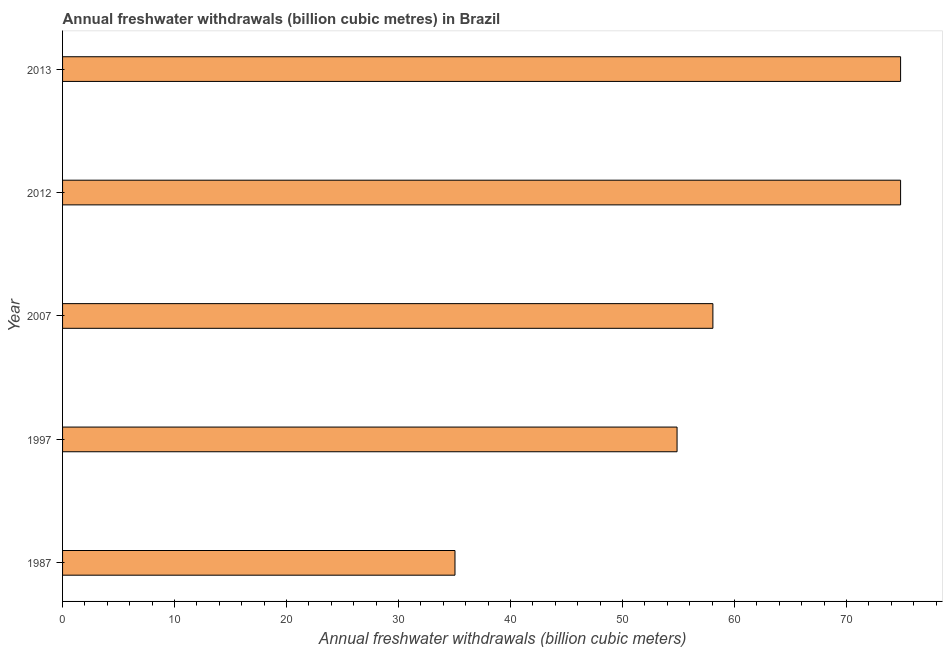What is the title of the graph?
Offer a very short reply. Annual freshwater withdrawals (billion cubic metres) in Brazil. What is the label or title of the X-axis?
Offer a terse response. Annual freshwater withdrawals (billion cubic meters). What is the annual freshwater withdrawals in 2013?
Your response must be concise. 74.83. Across all years, what is the maximum annual freshwater withdrawals?
Provide a succinct answer. 74.83. Across all years, what is the minimum annual freshwater withdrawals?
Your answer should be compact. 35.04. In which year was the annual freshwater withdrawals minimum?
Your answer should be compact. 1987. What is the sum of the annual freshwater withdrawals?
Your response must be concise. 297.64. What is the difference between the annual freshwater withdrawals in 1997 and 2013?
Your response must be concise. -19.96. What is the average annual freshwater withdrawals per year?
Give a very brief answer. 59.53. What is the median annual freshwater withdrawals?
Keep it short and to the point. 58.07. What is the ratio of the annual freshwater withdrawals in 1997 to that in 2013?
Ensure brevity in your answer.  0.73. What is the difference between the highest and the second highest annual freshwater withdrawals?
Offer a very short reply. 0. What is the difference between the highest and the lowest annual freshwater withdrawals?
Offer a terse response. 39.79. In how many years, is the annual freshwater withdrawals greater than the average annual freshwater withdrawals taken over all years?
Give a very brief answer. 2. Are all the bars in the graph horizontal?
Give a very brief answer. Yes. How many years are there in the graph?
Provide a succinct answer. 5. What is the difference between two consecutive major ticks on the X-axis?
Keep it short and to the point. 10. What is the Annual freshwater withdrawals (billion cubic meters) of 1987?
Offer a very short reply. 35.04. What is the Annual freshwater withdrawals (billion cubic meters) in 1997?
Your answer should be compact. 54.87. What is the Annual freshwater withdrawals (billion cubic meters) of 2007?
Your answer should be compact. 58.07. What is the Annual freshwater withdrawals (billion cubic meters) in 2012?
Make the answer very short. 74.83. What is the Annual freshwater withdrawals (billion cubic meters) of 2013?
Your answer should be compact. 74.83. What is the difference between the Annual freshwater withdrawals (billion cubic meters) in 1987 and 1997?
Give a very brief answer. -19.83. What is the difference between the Annual freshwater withdrawals (billion cubic meters) in 1987 and 2007?
Provide a short and direct response. -23.03. What is the difference between the Annual freshwater withdrawals (billion cubic meters) in 1987 and 2012?
Offer a terse response. -39.79. What is the difference between the Annual freshwater withdrawals (billion cubic meters) in 1987 and 2013?
Your answer should be compact. -39.79. What is the difference between the Annual freshwater withdrawals (billion cubic meters) in 1997 and 2007?
Your response must be concise. -3.2. What is the difference between the Annual freshwater withdrawals (billion cubic meters) in 1997 and 2012?
Your answer should be very brief. -19.96. What is the difference between the Annual freshwater withdrawals (billion cubic meters) in 1997 and 2013?
Give a very brief answer. -19.96. What is the difference between the Annual freshwater withdrawals (billion cubic meters) in 2007 and 2012?
Keep it short and to the point. -16.76. What is the difference between the Annual freshwater withdrawals (billion cubic meters) in 2007 and 2013?
Your answer should be compact. -16.76. What is the difference between the Annual freshwater withdrawals (billion cubic meters) in 2012 and 2013?
Offer a very short reply. 0. What is the ratio of the Annual freshwater withdrawals (billion cubic meters) in 1987 to that in 1997?
Make the answer very short. 0.64. What is the ratio of the Annual freshwater withdrawals (billion cubic meters) in 1987 to that in 2007?
Ensure brevity in your answer.  0.6. What is the ratio of the Annual freshwater withdrawals (billion cubic meters) in 1987 to that in 2012?
Ensure brevity in your answer.  0.47. What is the ratio of the Annual freshwater withdrawals (billion cubic meters) in 1987 to that in 2013?
Your answer should be compact. 0.47. What is the ratio of the Annual freshwater withdrawals (billion cubic meters) in 1997 to that in 2007?
Ensure brevity in your answer.  0.94. What is the ratio of the Annual freshwater withdrawals (billion cubic meters) in 1997 to that in 2012?
Your answer should be very brief. 0.73. What is the ratio of the Annual freshwater withdrawals (billion cubic meters) in 1997 to that in 2013?
Ensure brevity in your answer.  0.73. What is the ratio of the Annual freshwater withdrawals (billion cubic meters) in 2007 to that in 2012?
Give a very brief answer. 0.78. What is the ratio of the Annual freshwater withdrawals (billion cubic meters) in 2007 to that in 2013?
Keep it short and to the point. 0.78. 